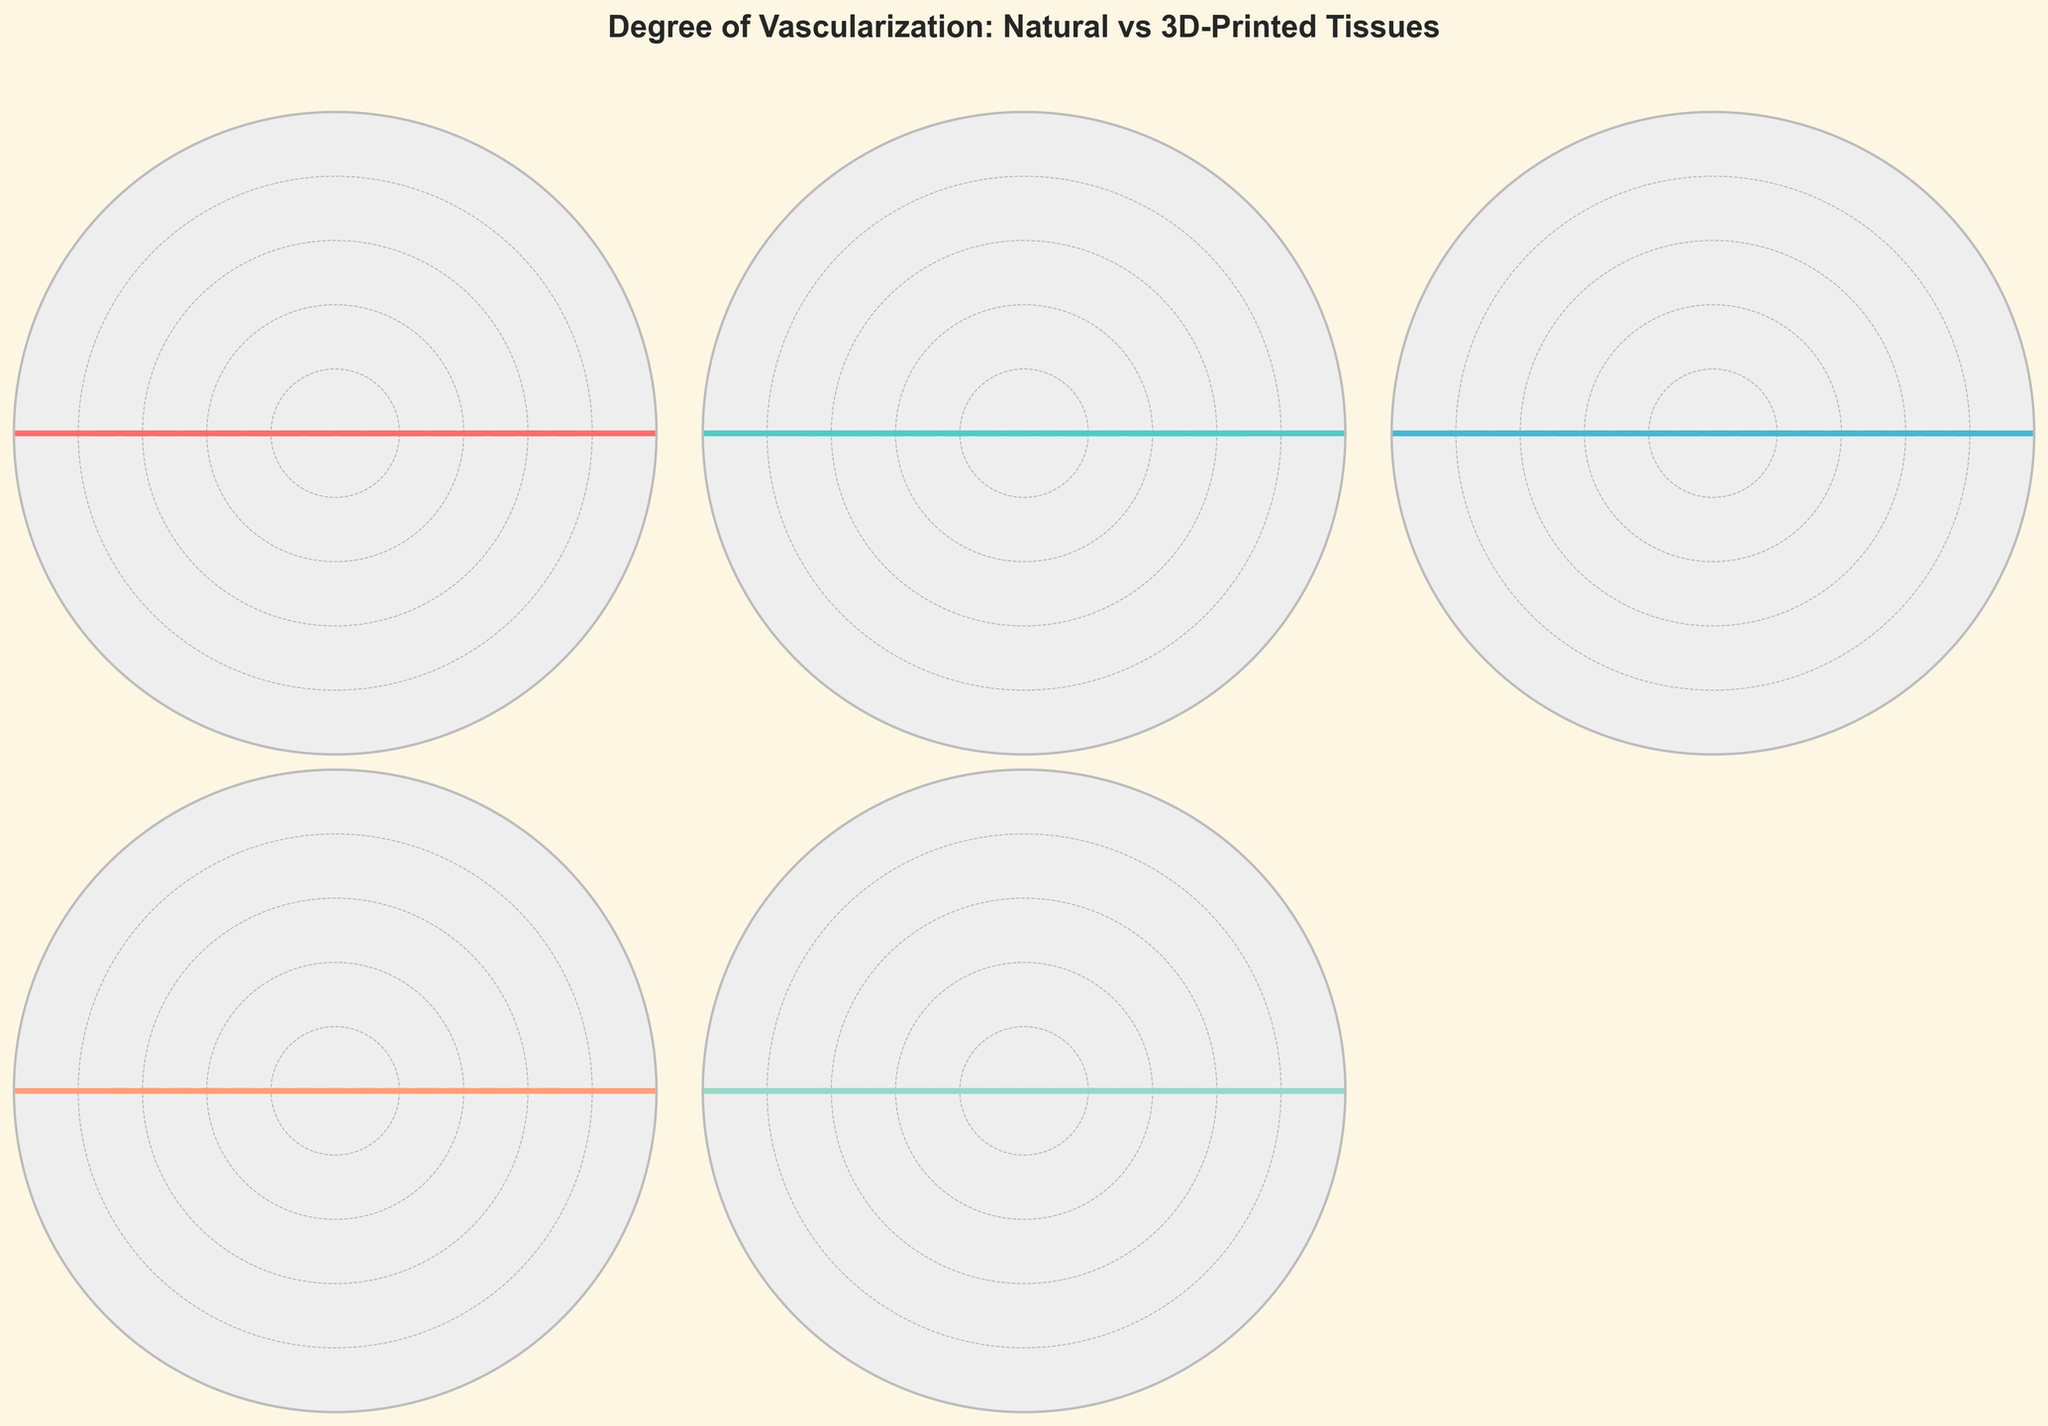What is the percentage of vascularization achieved in the 3D-printed kidney organoid? Look for the percentage associated with the 3D-printed kidney organoid in the figure text.
Answer: 65% What is the title of the figure? Look at the top of the figure where the title is usually placed.
Answer: Degree of Vascularization: Natural vs 3D-Printed Tissues Which 3D-printed tissue achieved the highest degree of vascularization? Compare the percentages of vascularization achieved by each 3D-printed tissue.
Answer: 3D-Printed Skin Graft By how much does the vascularization percentage of the 3D-printed liver construct differ from natural liver tissue? Subtract the percentage of vascularization in the 3D-printed liver construct from that in natural liver tissue.
Answer: 32% What is the average degree of vascularization for all 3D-printed tissues? Add the percentages of vascularization for all 3D-printed tissues and divide by the number of tissues. The values are 75, 68, 82, 70, and 65. Thus, (75 + 68 + 82 + 70 + 65) / 5 = 72
Answer: 72 Which tissue shows the largest difference in vascularization between natural and 3D-printed forms? Identify the tissue with the largest percentage difference between natural and 3D-printed vascularization.
Answer: Kidney Are there any tissues where the 3D-printed version achieves more than 80% vascularization compared to their natural counterpart? Look at the vascularization percentages of all 3D-printed tissues and see if any are above 80%.
Answer: Yes, Skin Graft How many tissues are depicted in the overall figure? Count the number of tissue types displayed in the subplots of the figure.
Answer: 6 